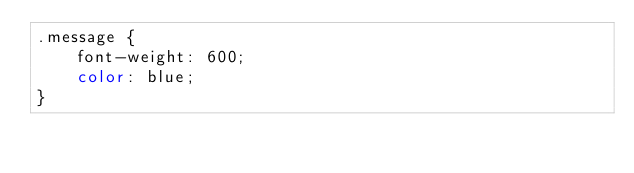Convert code to text. <code><loc_0><loc_0><loc_500><loc_500><_CSS_>.message {
    font-weight: 600;
    color: blue;
}</code> 